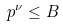Convert formula to latex. <formula><loc_0><loc_0><loc_500><loc_500>p ^ { \nu } \leq B</formula> 